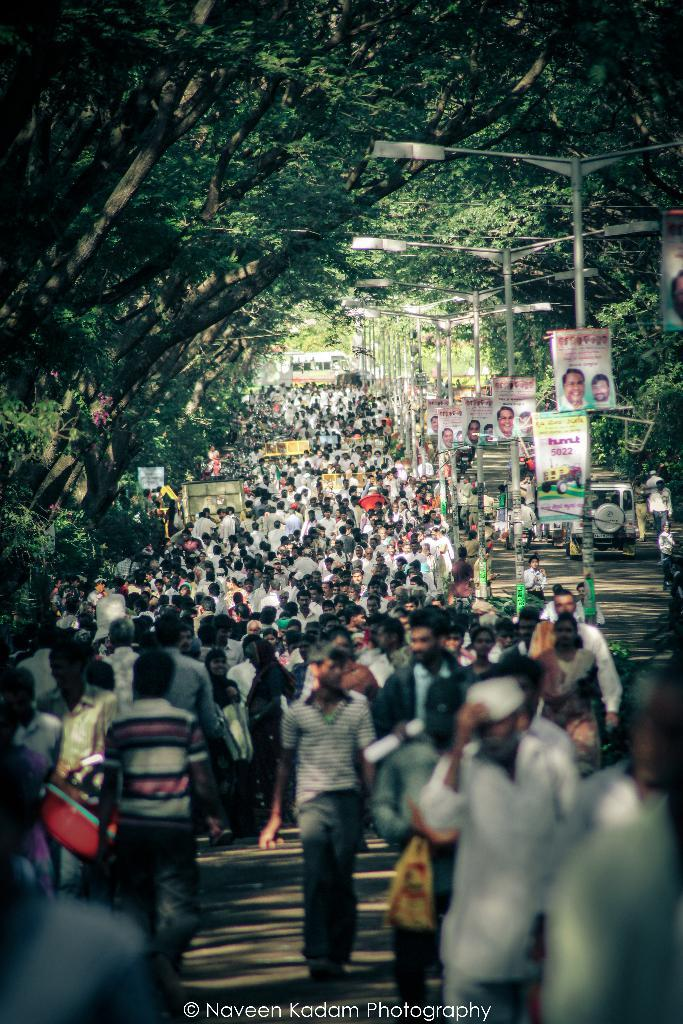How many people are visible in the image? There are people in the image, but the exact number cannot be determined from the provided facts. What type of infrastructure can be seen in the image? There is a road, poles, lights, and posters visible in the image. What type of transportation can be seen in the image? There are vehicles in the image. What type of vegetation is present in the image? There are trees in the image. Is there any text or branding visible in the image? There is a watermark in the bottom of the picture. What is the rate of the pencil in the image? There is no pencil present in the image, so it is not possible to determine its rate. How many airports can be seen in the image? There is no airport visible in the image. 